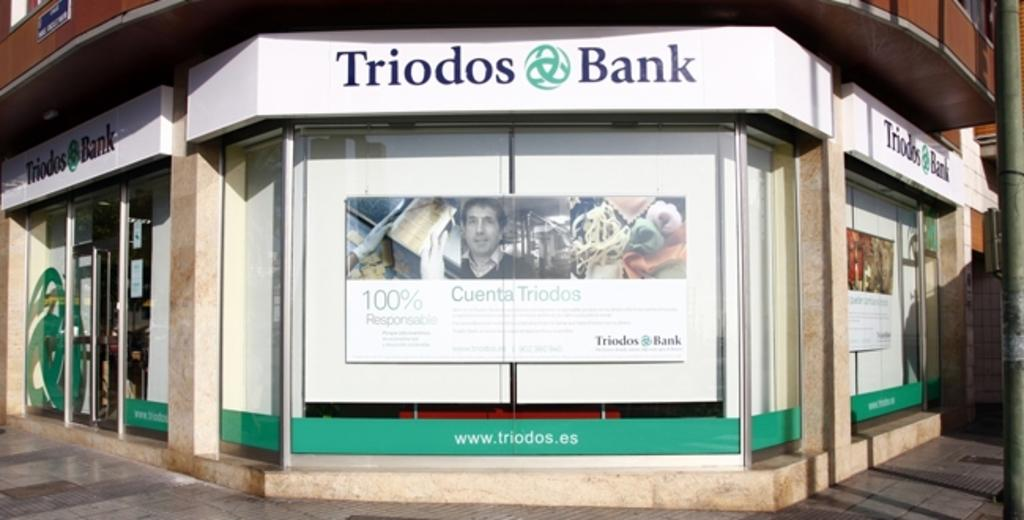What is the main subject in the center of the image? There is a poster in the center of the image. What is written on the poster? "Triodos bank" is written on the poster. What can be seen on the left side of the image? There is a door on the left side of the image. What is present on the right side of the image? There is a pole on the right side of the image. Can you see the seashore in the background of the image? There is no seashore visible in the image; it features a poster, a door, and a pole. What type of pot is being used to hold the fog in the image? There is no pot or fog present in the image. 